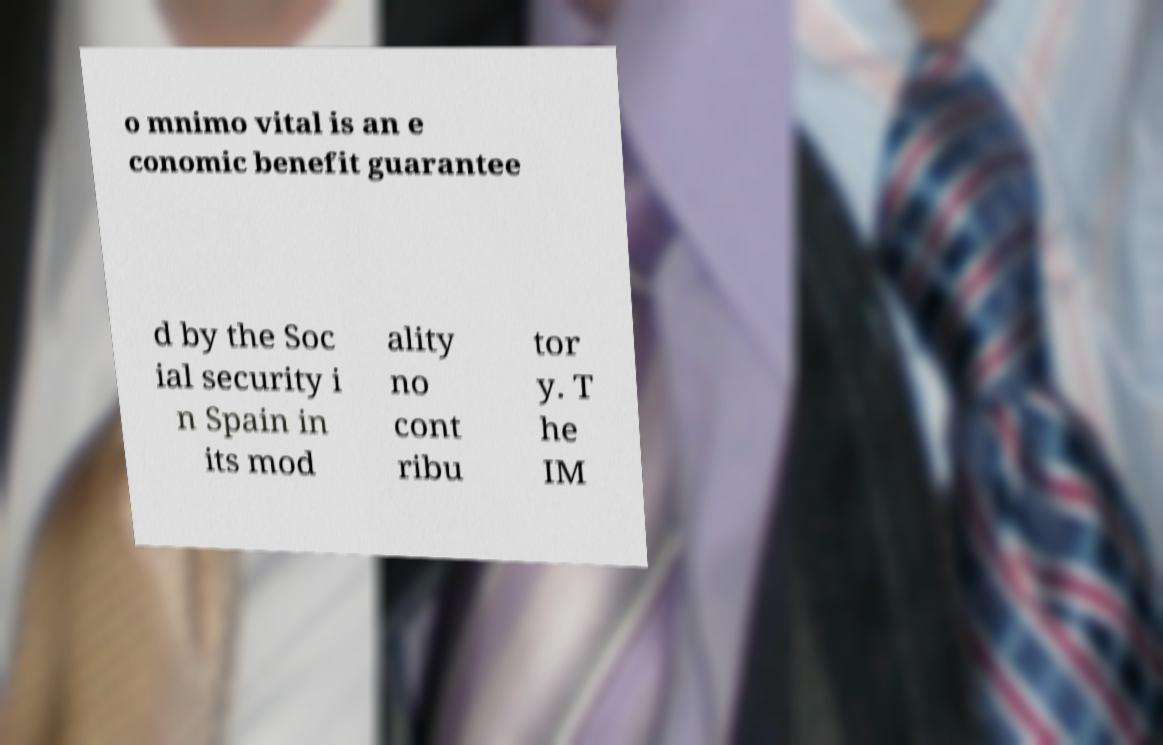There's text embedded in this image that I need extracted. Can you transcribe it verbatim? o mnimo vital is an e conomic benefit guarantee d by the Soc ial security i n Spain in its mod ality no cont ribu tor y. T he IM 